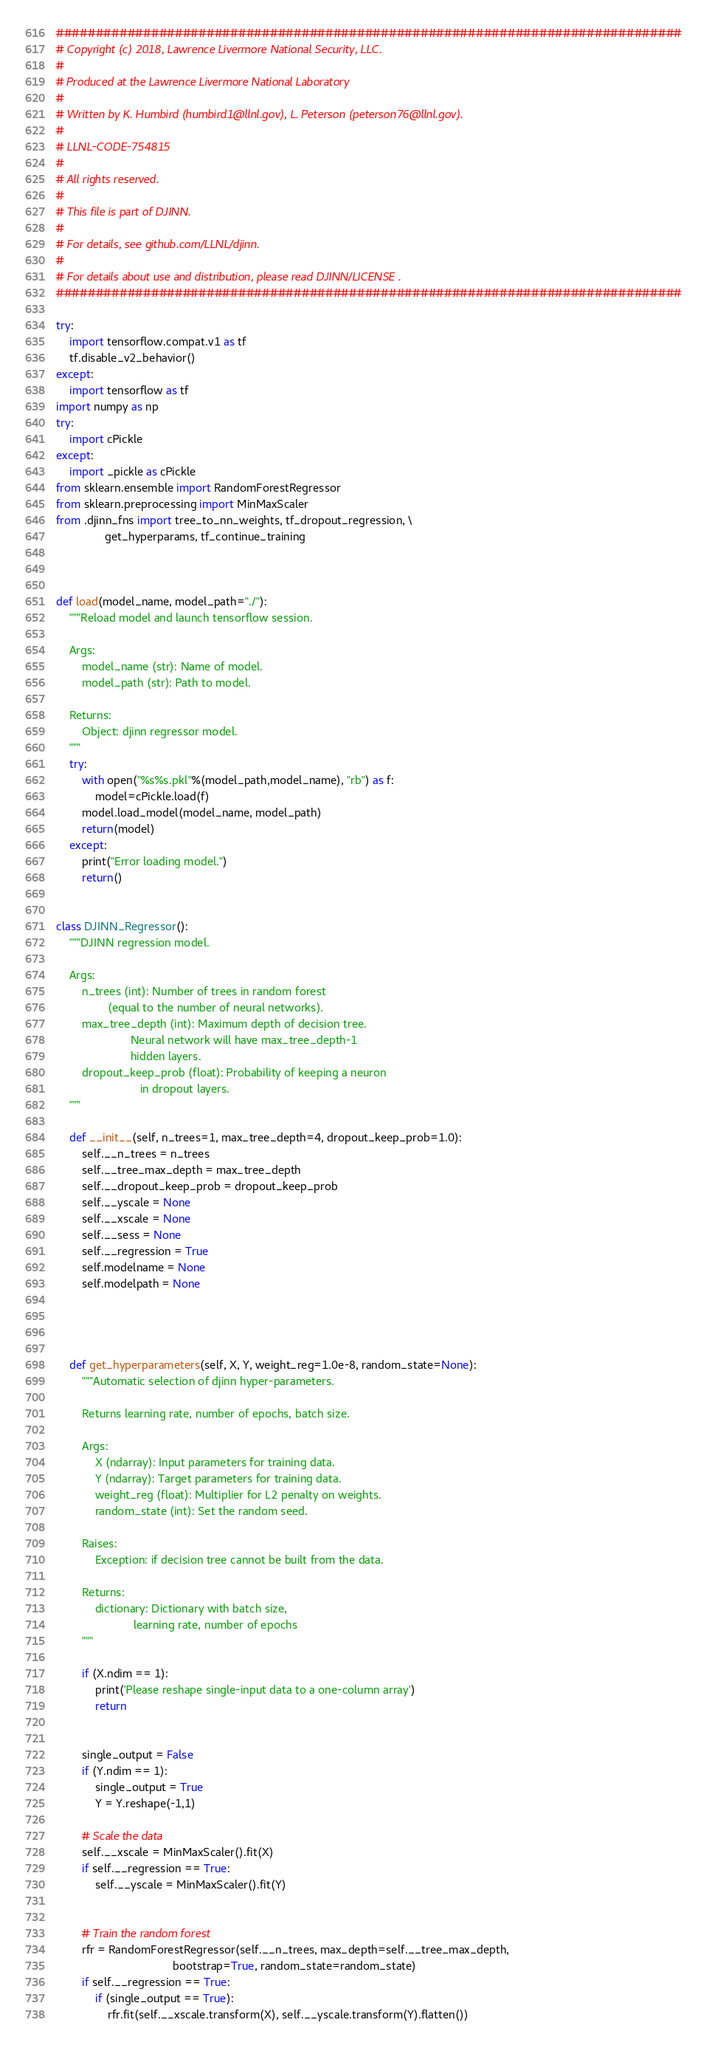<code> <loc_0><loc_0><loc_500><loc_500><_Python_>###############################################################################
# Copyright (c) 2018, Lawrence Livermore National Security, LLC.
# 
# Produced at the Lawrence Livermore National Laboratory
#
# Written by K. Humbird (humbird1@llnl.gov), L. Peterson (peterson76@llnl.gov).
#
# LLNL-CODE-754815
#
# All rights reserved.
#
# This file is part of DJINN.
#
# For details, see github.com/LLNL/djinn. 
#
# For details about use and distribution, please read DJINN/LICENSE .
###############################################################################

try: 
    import tensorflow.compat.v1 as tf
    tf.disable_v2_behavior()
except: 
    import tensorflow as tf
import numpy as np
try: 
    import cPickle
except: 
    import _pickle as cPickle
from sklearn.ensemble import RandomForestRegressor
from sklearn.preprocessing import MinMaxScaler
from .djinn_fns import tree_to_nn_weights, tf_dropout_regression, \
               get_hyperparams, tf_continue_training



def load(model_name, model_path="./"):
    """Reload model and launch tensorflow session.

    Args:
        model_name (str): Name of model.
        model_path (str): Path to model.
        
    Returns: 
        Object: djinn regressor model.
    """
    try:
        with open("%s%s.pkl"%(model_path,model_name), "rb") as f:
            model=cPickle.load(f) 
        model.load_model(model_name, model_path)
        return(model)
    except: 
        print("Error loading model.")
        return() 


class DJINN_Regressor():
    """DJINN regression model.

    Args:
        n_trees (int): Number of trees in random forest 
                (equal to the number of neural networks).
        max_tree_depth (int): Maximum depth of decision tree. 
                       Neural network will have max_tree_depth-1 
                       hidden layers.
        dropout_keep_prob (float): Probability of keeping a neuron
                          in dropout layers.  
    """

    def __init__(self, n_trees=1, max_tree_depth=4, dropout_keep_prob=1.0):
        self.__n_trees = n_trees 
        self.__tree_max_depth = max_tree_depth
        self.__dropout_keep_prob = dropout_keep_prob
        self.__yscale = None
        self.__xscale = None
        self.__sess = None
        self.__regression = True
        self.modelname = None
        self.modelpath = None




    def get_hyperparameters(self, X, Y, weight_reg=1.0e-8, random_state=None):
        """Automatic selection of djinn hyper-parameters.
        
        Returns learning rate, number of epochs, batch size.
        
        Args: 
            X (ndarray): Input parameters for training data.
            Y (ndarray): Target parameters for training data. 
            weight_reg (float): Multiplier for L2 penalty on weights.
            random_state (int): Set the random seed. 

        Raises:
            Exception: if decision tree cannot be built from the data.

        Returns: 
            dictionary: Dictionary with batch size, 
                        learning rate, number of epochs
        """

        if (X.ndim == 1): 
            print('Please reshape single-input data to a one-column array')
            return


        single_output = False
        if (Y.ndim == 1): 
            single_output = True
            Y = Y.reshape(-1,1)

        # Scale the data
        self.__xscale = MinMaxScaler().fit(X)
        if self.__regression == True: 
            self.__yscale = MinMaxScaler().fit(Y)


        # Train the random forest
        rfr = RandomForestRegressor(self.__n_trees, max_depth=self.__tree_max_depth,
                                    bootstrap=True, random_state=random_state)
        if self.__regression == True: 
            if (single_output == True): 
                rfr.fit(self.__xscale.transform(X), self.__yscale.transform(Y).flatten())</code> 